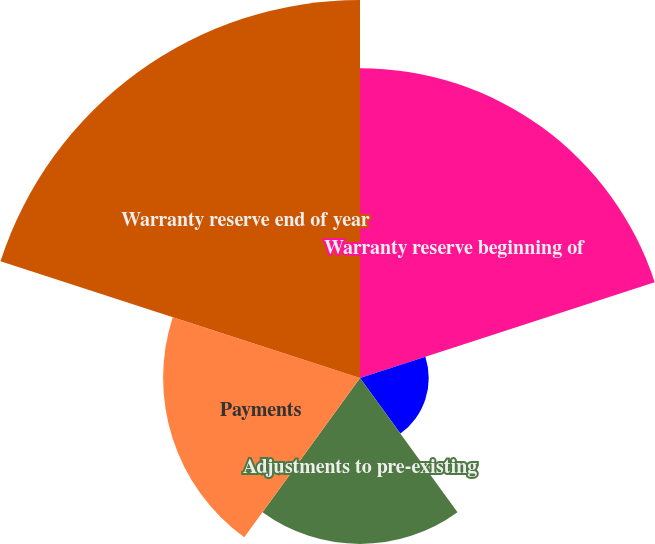Convert chart. <chart><loc_0><loc_0><loc_500><loc_500><pie_chart><fcel>Warranty reserve beginning of<fcel>Warranties issued during the<fcel>Adjustments to pre-existing<fcel>Payments<fcel>Warranty reserve end of year<nl><fcel>27.68%<fcel>6.14%<fcel>14.82%<fcel>17.59%<fcel>33.77%<nl></chart> 